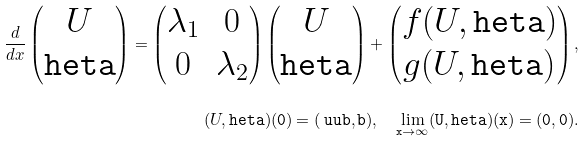<formula> <loc_0><loc_0><loc_500><loc_500>\frac { d } { d x } \begin{pmatrix} U \\ \tt h e t a \end{pmatrix} = \begin{pmatrix} \lambda _ { 1 } & 0 \\ 0 & \lambda _ { 2 } \end{pmatrix} \begin{pmatrix} U \\ \tt h e t a \end{pmatrix} + \begin{pmatrix} f ( U , \tt h e t a ) \\ g ( U , \tt h e t a ) \end{pmatrix} , \\ ( U , \tt h e t a ) ( 0 ) = ( \ u u b , \tt b ) , \quad \lim _ { x \to \infty } ( U , \tt h e t a ) ( x ) = ( 0 , 0 ) .</formula> 